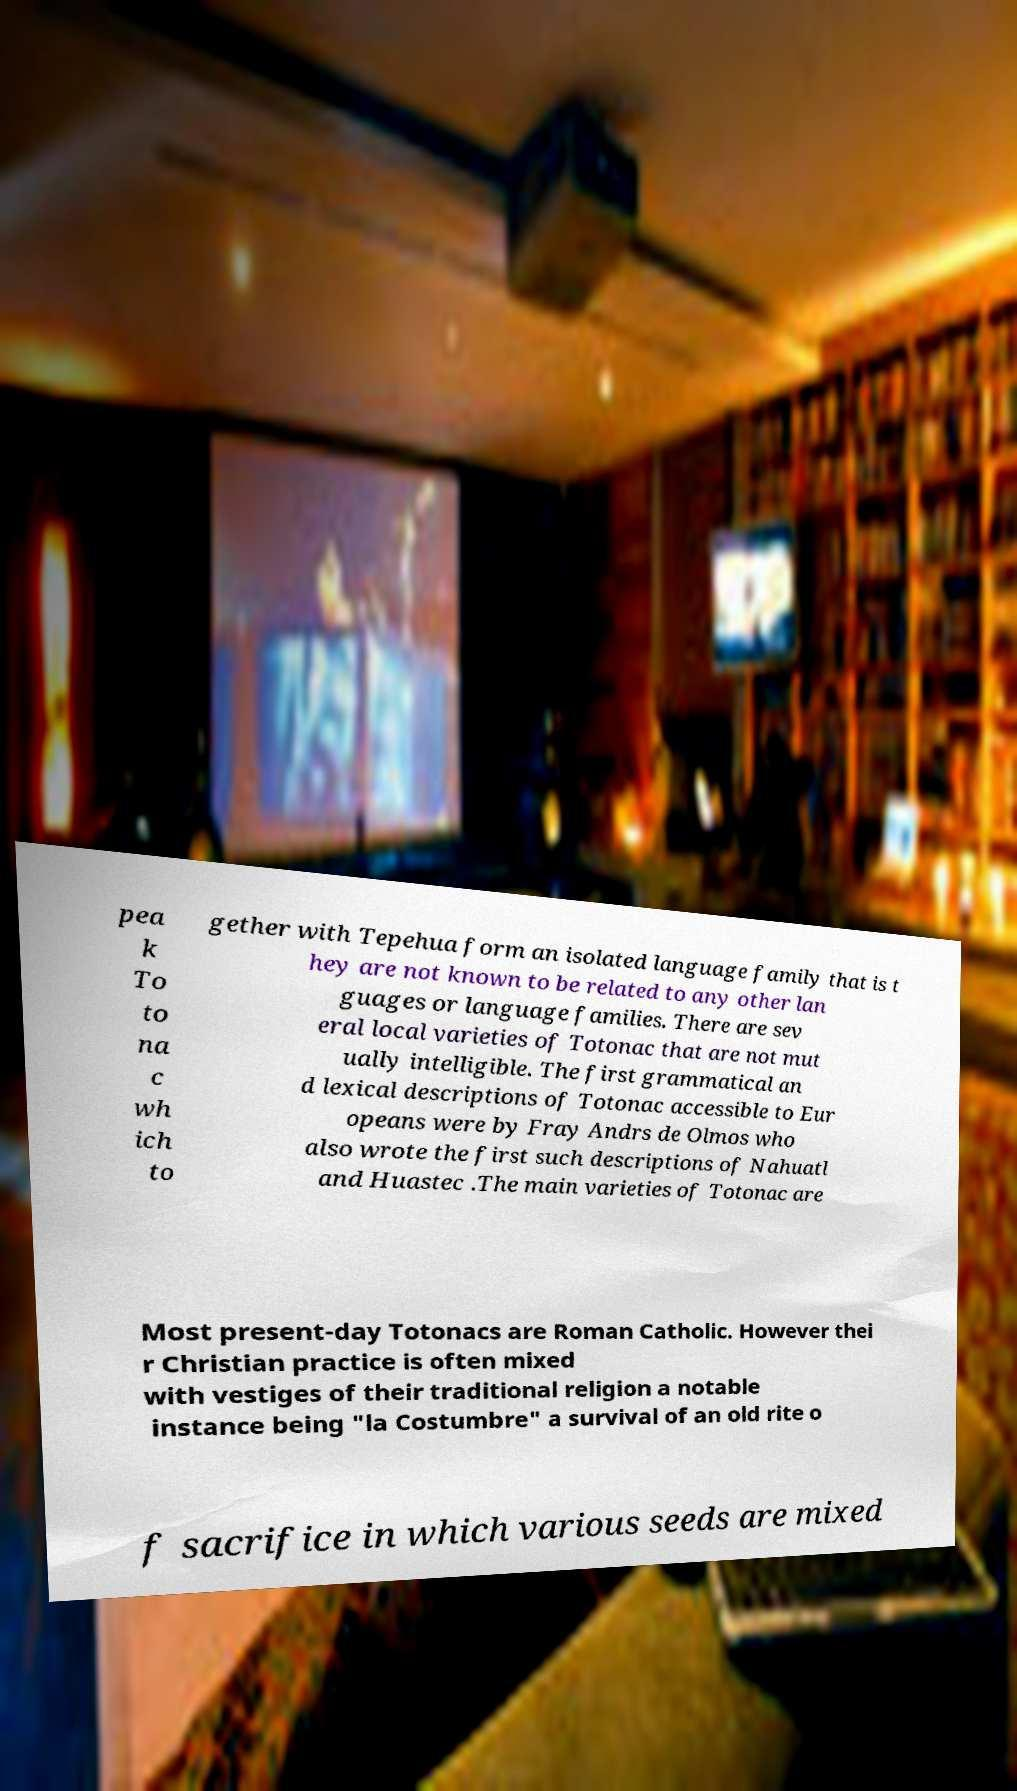Please identify and transcribe the text found in this image. pea k To to na c wh ich to gether with Tepehua form an isolated language family that is t hey are not known to be related to any other lan guages or language families. There are sev eral local varieties of Totonac that are not mut ually intelligible. The first grammatical an d lexical descriptions of Totonac accessible to Eur opeans were by Fray Andrs de Olmos who also wrote the first such descriptions of Nahuatl and Huastec .The main varieties of Totonac are Most present-day Totonacs are Roman Catholic. However thei r Christian practice is often mixed with vestiges of their traditional religion a notable instance being "la Costumbre" a survival of an old rite o f sacrifice in which various seeds are mixed 